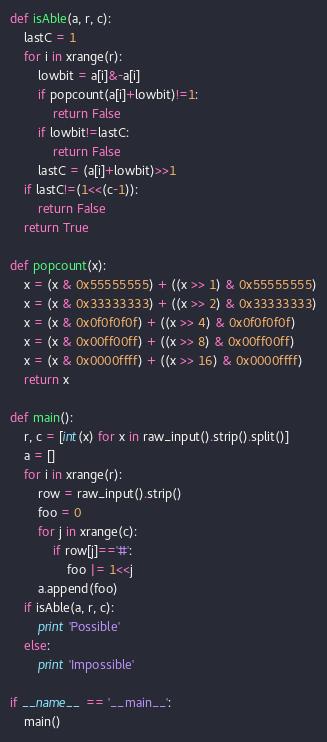Convert code to text. <code><loc_0><loc_0><loc_500><loc_500><_Python_>def isAble(a, r, c):
    lastC = 1
    for i in xrange(r):
        lowbit = a[i]&-a[i]
        if popcount(a[i]+lowbit)!=1:
            return False
        if lowbit!=lastC:
            return False
        lastC = (a[i]+lowbit)>>1
    if lastC!=(1<<(c-1)):
        return False
    return True

def popcount(x):
    x = (x & 0x55555555) + ((x >> 1) & 0x55555555)
    x = (x & 0x33333333) + ((x >> 2) & 0x33333333)
    x = (x & 0x0f0f0f0f) + ((x >> 4) & 0x0f0f0f0f)
    x = (x & 0x00ff00ff) + ((x >> 8) & 0x00ff00ff)
    x = (x & 0x0000ffff) + ((x >> 16) & 0x0000ffff)
    return x

def main():
    r, c = [int(x) for x in raw_input().strip().split()]
    a = []
    for i in xrange(r):
        row = raw_input().strip()
        foo = 0
        for j in xrange(c):
            if row[j]=='#':
                foo |= 1<<j
        a.append(foo)
    if isAble(a, r, c):
        print 'Possible'
    else:
        print 'Impossible'

if __name__ == '__main__':
    main()</code> 